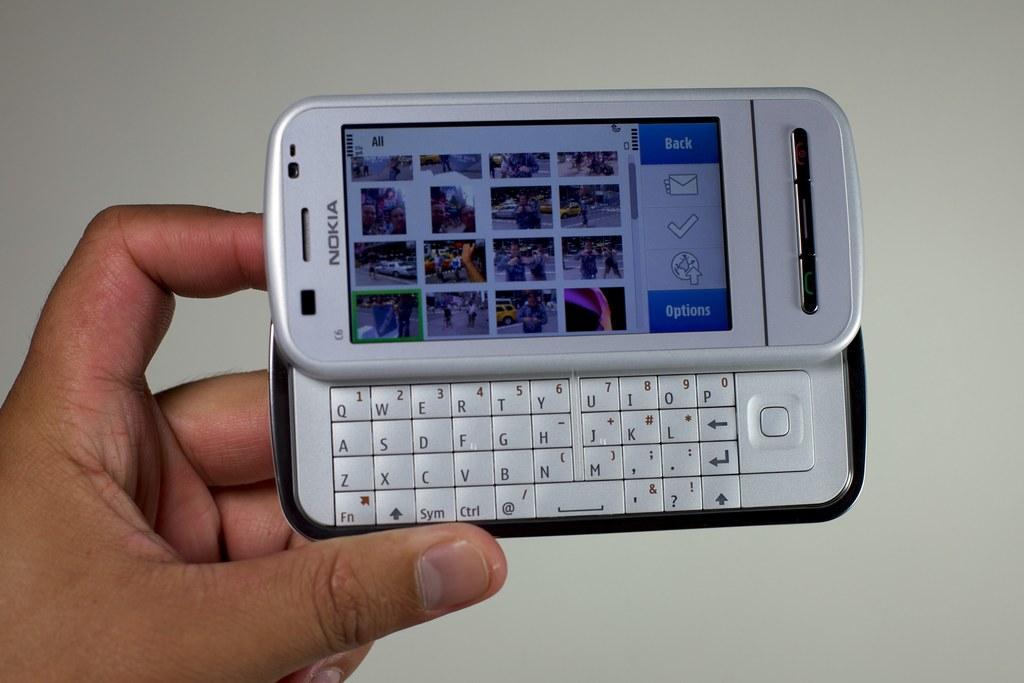Describe this image in one or two sentences. In the center of the image we can see one hand holding a mobile phone, in which we can see keypad and photo collections on the screen. On the phone, it is written as "Nokia". In the background there is a wall. 